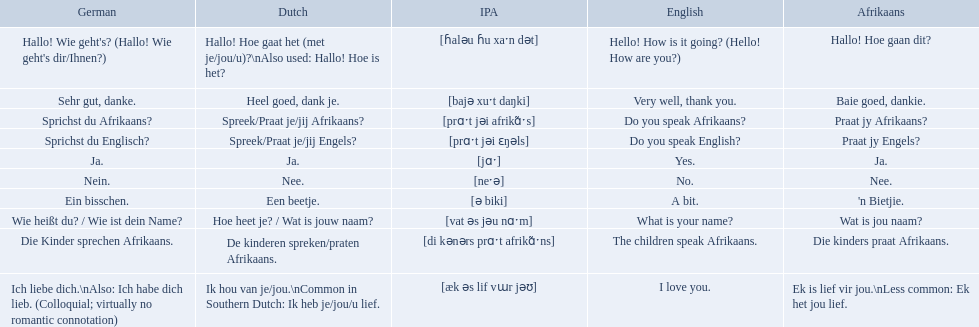How do you say hello! how is it going? in afrikaans? Hallo! Hoe gaan dit?. How do you say very well, thank you in afrikaans? Baie goed, dankie. How would you say do you speak afrikaans? in afrikaans? Praat jy Afrikaans?. In german how do you say do you speak afrikaans? Sprichst du Afrikaans?. How do you say it in afrikaans? Praat jy Afrikaans?. 